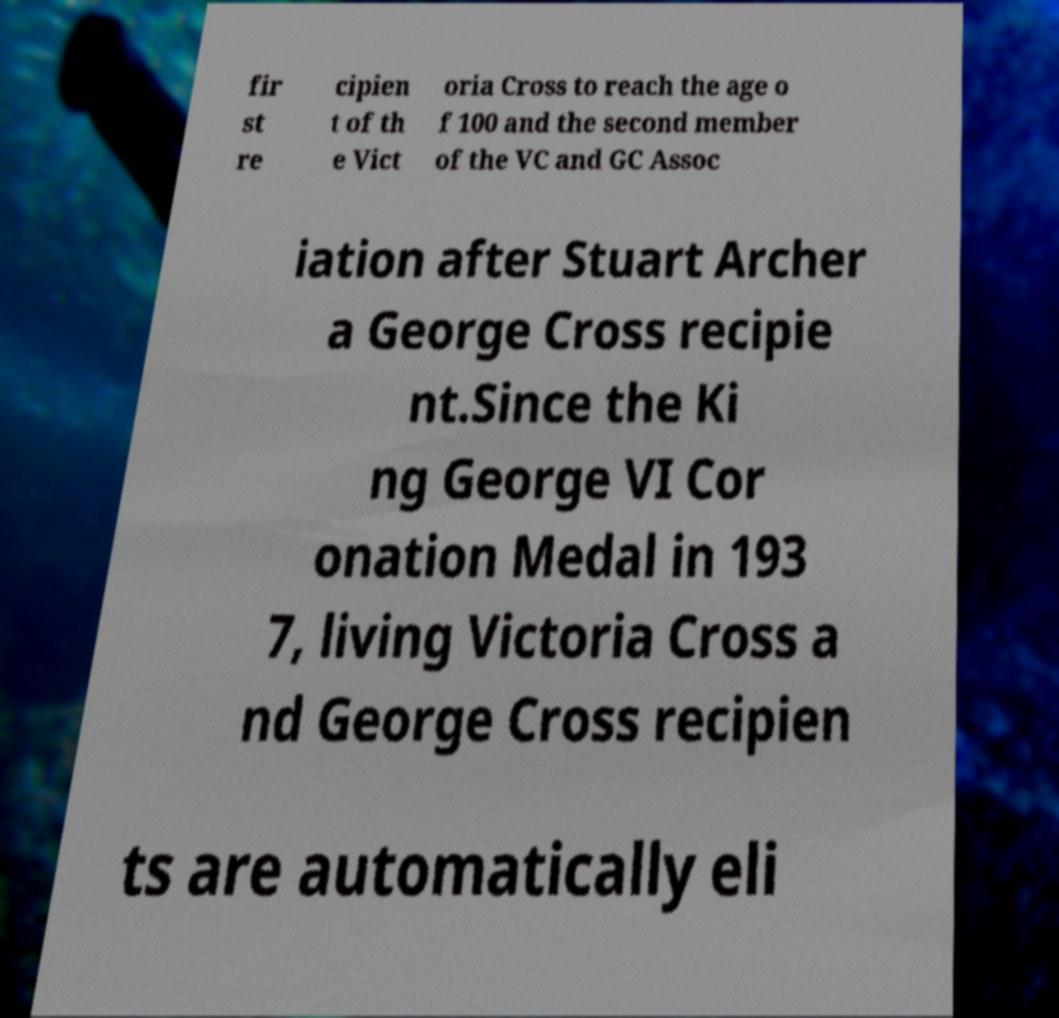Can you read and provide the text displayed in the image?This photo seems to have some interesting text. Can you extract and type it out for me? fir st re cipien t of th e Vict oria Cross to reach the age o f 100 and the second member of the VC and GC Assoc iation after Stuart Archer a George Cross recipie nt.Since the Ki ng George VI Cor onation Medal in 193 7, living Victoria Cross a nd George Cross recipien ts are automatically eli 